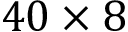<formula> <loc_0><loc_0><loc_500><loc_500>4 0 \times 8</formula> 